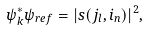<formula> <loc_0><loc_0><loc_500><loc_500>\psi _ { k } ^ { \ast } \psi _ { r e f } = | s ( j _ { l } , i _ { n } ) | ^ { 2 } ,</formula> 